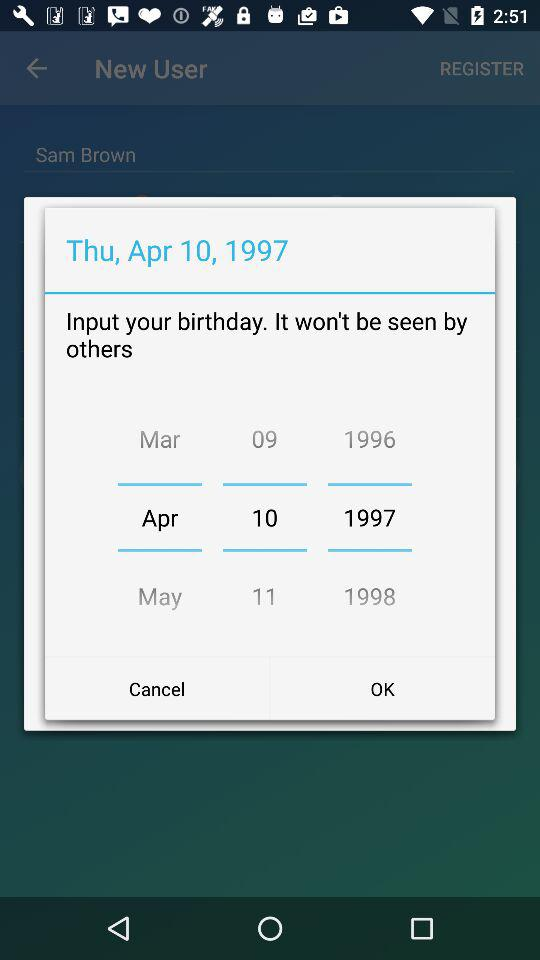What is the day on Apr 10, 1997? The day on April 10, 1997 is Thursday. 